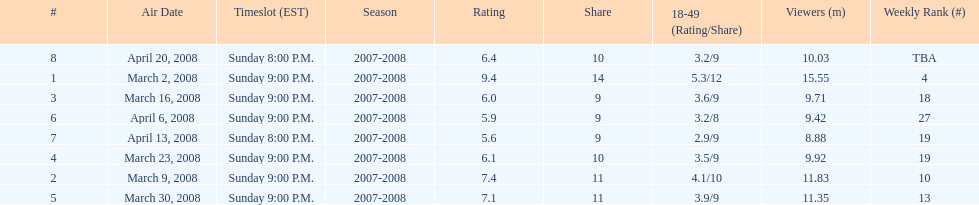Did the season finish at an earlier or later timeslot? Earlier. 